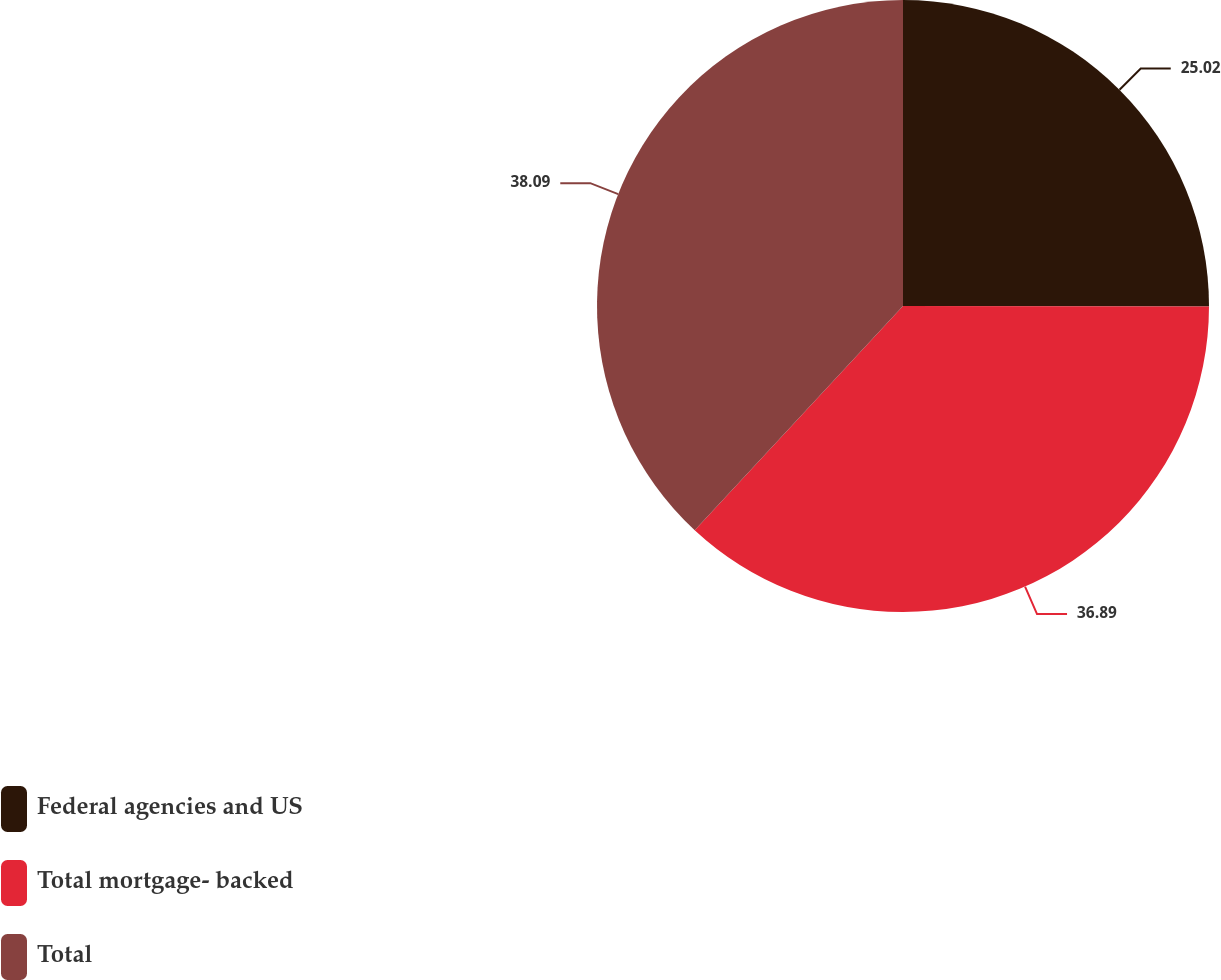Convert chart to OTSL. <chart><loc_0><loc_0><loc_500><loc_500><pie_chart><fcel>Federal agencies and US<fcel>Total mortgage- backed<fcel>Total<nl><fcel>25.02%<fcel>36.89%<fcel>38.08%<nl></chart> 